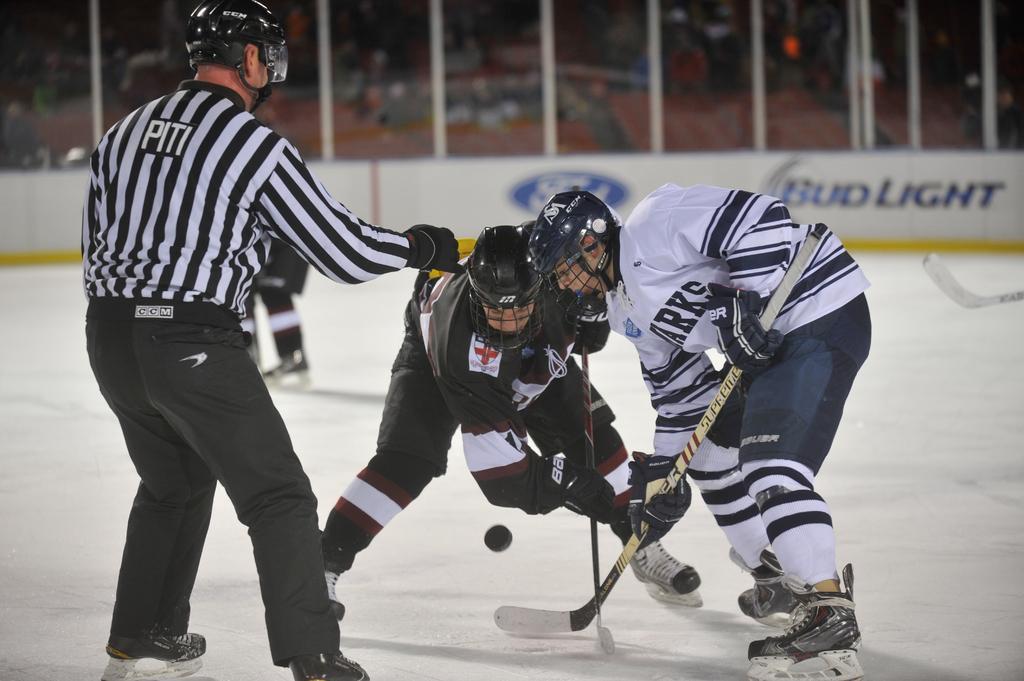Could you give a brief overview of what you see in this image? In this image, I can see two people holding the hockey bats and playing the ice hockey game. This is a person standing. In the background, these look like the hoardings. On the right side of the image, I can see another hockey bat. 